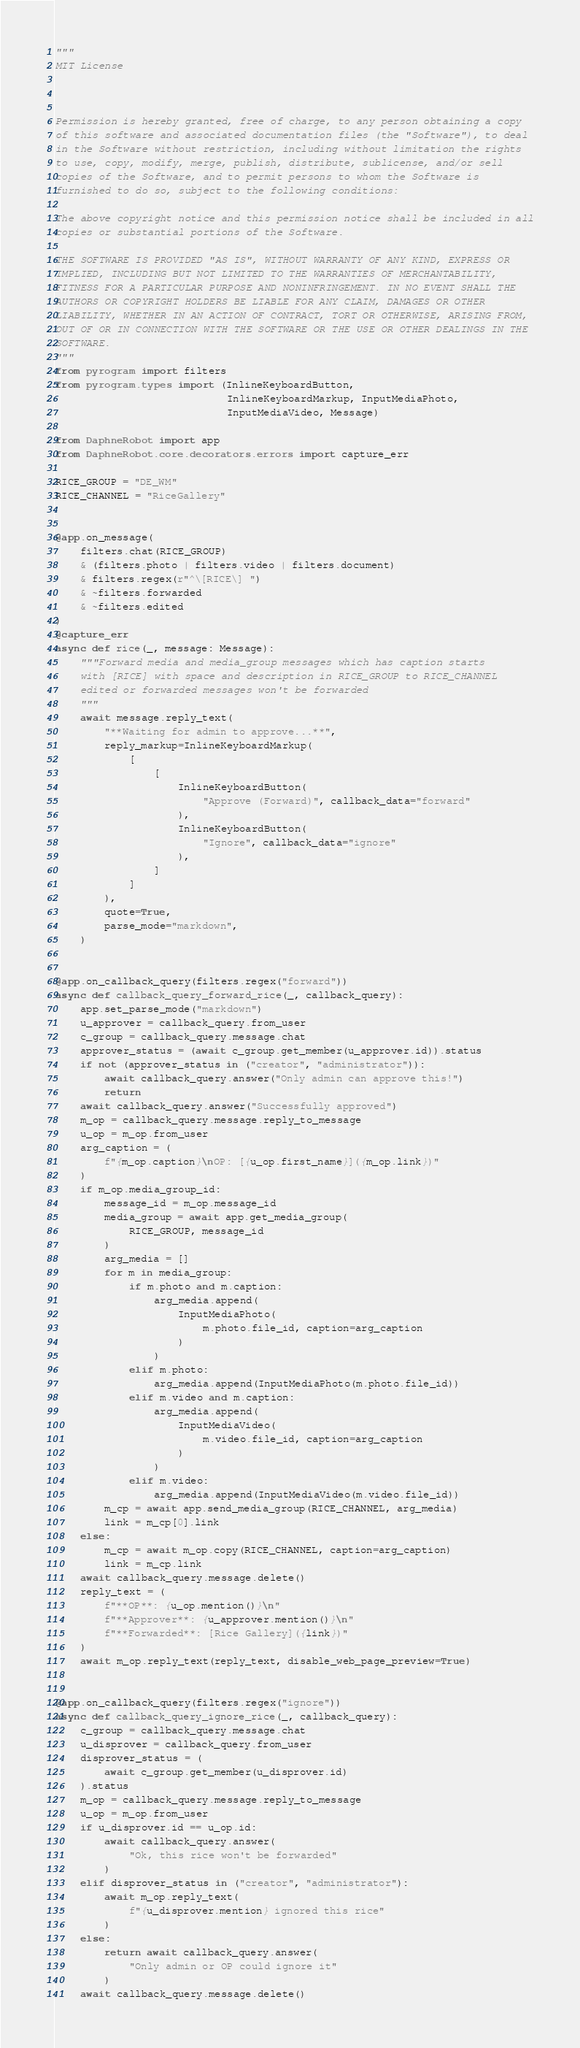Convert code to text. <code><loc_0><loc_0><loc_500><loc_500><_Python_>"""
MIT License



Permission is hereby granted, free of charge, to any person obtaining a copy
of this software and associated documentation files (the "Software"), to deal
in the Software without restriction, including without limitation the rights
to use, copy, modify, merge, publish, distribute, sublicense, and/or sell
copies of the Software, and to permit persons to whom the Software is
furnished to do so, subject to the following conditions:

The above copyright notice and this permission notice shall be included in all
copies or substantial portions of the Software.

THE SOFTWARE IS PROVIDED "AS IS", WITHOUT WARRANTY OF ANY KIND, EXPRESS OR
IMPLIED, INCLUDING BUT NOT LIMITED TO THE WARRANTIES OF MERCHANTABILITY,
FITNESS FOR A PARTICULAR PURPOSE AND NONINFRINGEMENT. IN NO EVENT SHALL THE
AUTHORS OR COPYRIGHT HOLDERS BE LIABLE FOR ANY CLAIM, DAMAGES OR OTHER
LIABILITY, WHETHER IN AN ACTION OF CONTRACT, TORT OR OTHERWISE, ARISING FROM,
OUT OF OR IN CONNECTION WITH THE SOFTWARE OR THE USE OR OTHER DEALINGS IN THE
SOFTWARE.
"""
from pyrogram import filters
from pyrogram.types import (InlineKeyboardButton,
                            InlineKeyboardMarkup, InputMediaPhoto,
                            InputMediaVideo, Message)

from DaphneRobot import app
from DaphneRobot.core.decorators.errors import capture_err

RICE_GROUP = "DE_WM"
RICE_CHANNEL = "RiceGallery"


@app.on_message(
    filters.chat(RICE_GROUP)
    & (filters.photo | filters.video | filters.document)
    & filters.regex(r"^\[RICE\] ")
    & ~filters.forwarded
    & ~filters.edited
)
@capture_err
async def rice(_, message: Message):
    """Forward media and media_group messages which has caption starts
    with [RICE] with space and description in RICE_GROUP to RICE_CHANNEL
    edited or forwarded messages won't be forwarded
    """
    await message.reply_text(
        "**Waiting for admin to approve...**",
        reply_markup=InlineKeyboardMarkup(
            [
                [
                    InlineKeyboardButton(
                        "Approve (Forward)", callback_data="forward"
                    ),
                    InlineKeyboardButton(
                        "Ignore", callback_data="ignore"
                    ),
                ]
            ]
        ),
        quote=True,
        parse_mode="markdown",
    )


@app.on_callback_query(filters.regex("forward"))
async def callback_query_forward_rice(_, callback_query):
    app.set_parse_mode("markdown")
    u_approver = callback_query.from_user
    c_group = callback_query.message.chat
    approver_status = (await c_group.get_member(u_approver.id)).status
    if not (approver_status in ("creator", "administrator")):
        await callback_query.answer("Only admin can approve this!")
        return
    await callback_query.answer("Successfully approved")
    m_op = callback_query.message.reply_to_message
    u_op = m_op.from_user
    arg_caption = (
        f"{m_op.caption}\nOP: [{u_op.first_name}]({m_op.link})"
    )
    if m_op.media_group_id:
        message_id = m_op.message_id
        media_group = await app.get_media_group(
            RICE_GROUP, message_id
        )
        arg_media = []
        for m in media_group:
            if m.photo and m.caption:
                arg_media.append(
                    InputMediaPhoto(
                        m.photo.file_id, caption=arg_caption
                    )
                )
            elif m.photo:
                arg_media.append(InputMediaPhoto(m.photo.file_id))
            elif m.video and m.caption:
                arg_media.append(
                    InputMediaVideo(
                        m.video.file_id, caption=arg_caption
                    )
                )
            elif m.video:
                arg_media.append(InputMediaVideo(m.video.file_id))
        m_cp = await app.send_media_group(RICE_CHANNEL, arg_media)
        link = m_cp[0].link
    else:
        m_cp = await m_op.copy(RICE_CHANNEL, caption=arg_caption)
        link = m_cp.link
    await callback_query.message.delete()
    reply_text = (
        f"**OP**: {u_op.mention()}\n"
        f"**Approver**: {u_approver.mention()}\n"
        f"**Forwarded**: [Rice Gallery]({link})"
    )
    await m_op.reply_text(reply_text, disable_web_page_preview=True)


@app.on_callback_query(filters.regex("ignore"))
async def callback_query_ignore_rice(_, callback_query):
    c_group = callback_query.message.chat
    u_disprover = callback_query.from_user
    disprover_status = (
        await c_group.get_member(u_disprover.id)
    ).status
    m_op = callback_query.message.reply_to_message
    u_op = m_op.from_user
    if u_disprover.id == u_op.id:
        await callback_query.answer(
            "Ok, this rice won't be forwarded"
        )
    elif disprover_status in ("creator", "administrator"):
        await m_op.reply_text(
            f"{u_disprover.mention} ignored this rice"
        )
    else:
        return await callback_query.answer(
            "Only admin or OP could ignore it"
        )
    await callback_query.message.delete()
</code> 